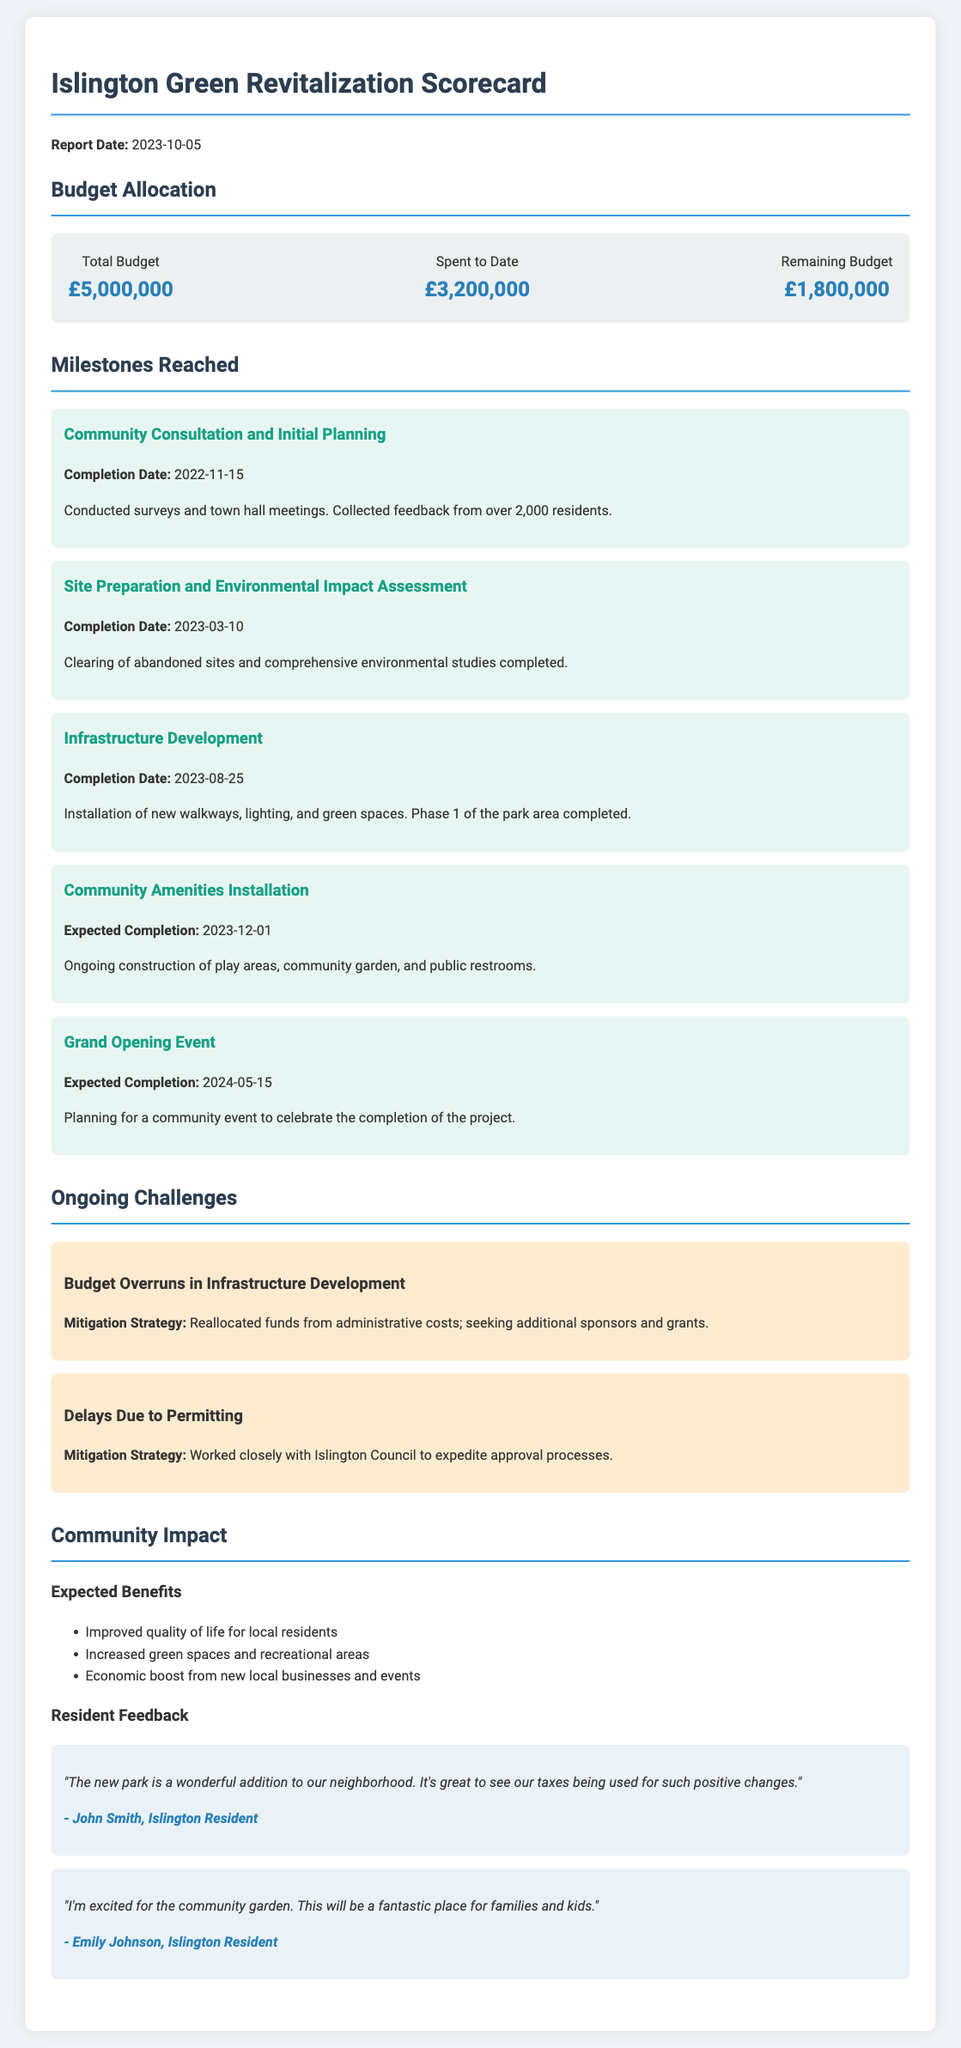What is the total budget? The total budget indicates the overall financial resources allocated for the project.
Answer: £5,000,000 How much has been spent to date? This amount reflects the financial expenditures made on the project up to the report date.
Answer: £3,200,000 What is the expected completion date for community amenities installation? The expected completion date signifies when the ongoing construction of community amenities is anticipated to finish.
Answer: 2023-12-01 What challenge involves budget overruns? This challenge pertains to a financial issue specifically linked to a particular segment of project implementation.
Answer: Budget Overruns in Infrastructure Development Who provided feedback stating the new park is a wonderful addition? This identifies a resident who expressed a positive opinion about the project's impact on the neighborhood.
Answer: John Smith, Islington Resident What is one of the expected benefits listed in the community impact section? This question asks for a specific advantage that the community expects to gain from the project according to the report.
Answer: Improved quality of life for local residents What mitigation strategy is mentioned for delays due to permitting? This outlines the approach taken to address specific delays encountered during project execution.
Answer: Worked closely with Islington Council to expedite approval processes What is the completion date for the infrastructure development milestone? This refers to the date when infrastructure-related work was completed as part of the project timeline.
Answer: 2023-08-25 